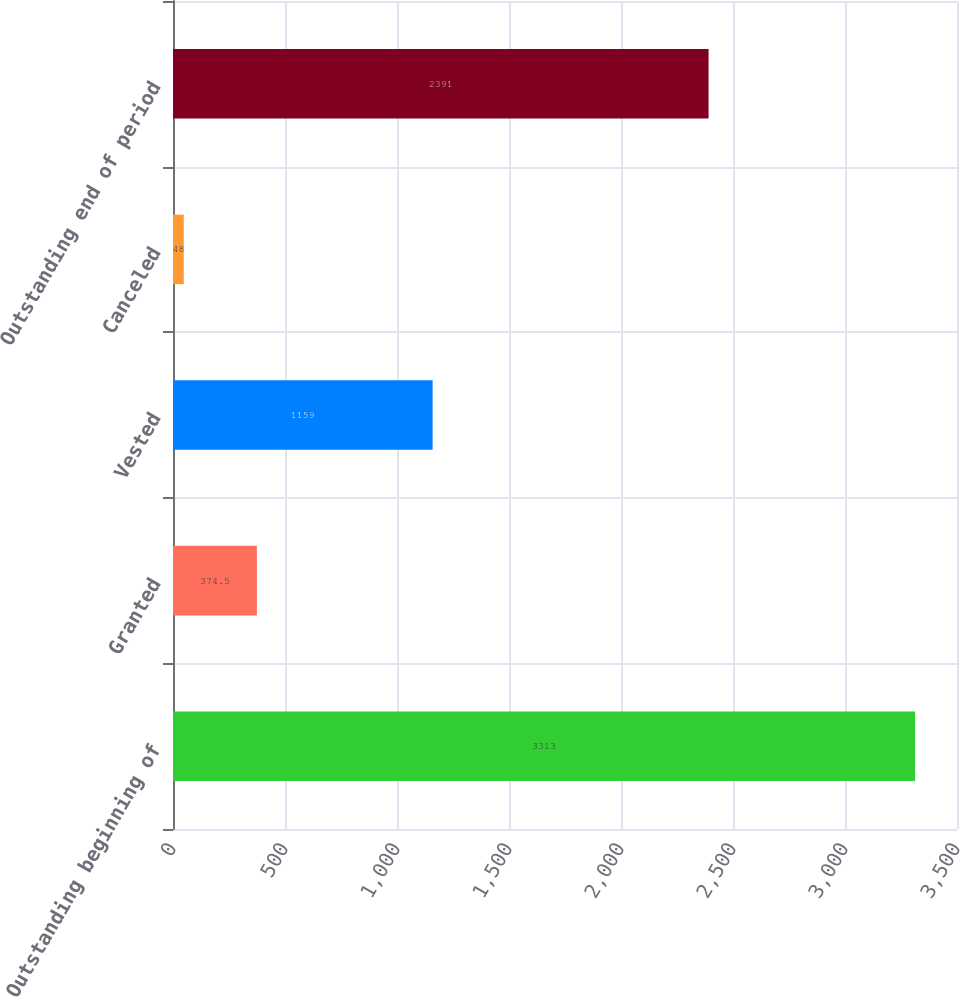<chart> <loc_0><loc_0><loc_500><loc_500><bar_chart><fcel>Outstanding beginning of<fcel>Granted<fcel>Vested<fcel>Canceled<fcel>Outstanding end of period<nl><fcel>3313<fcel>374.5<fcel>1159<fcel>48<fcel>2391<nl></chart> 